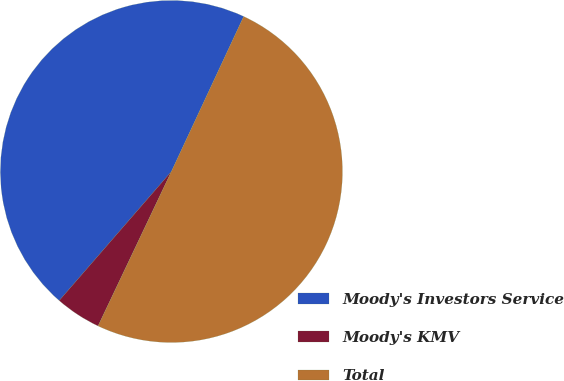<chart> <loc_0><loc_0><loc_500><loc_500><pie_chart><fcel>Moody's Investors Service<fcel>Moody's KMV<fcel>Total<nl><fcel>45.56%<fcel>4.33%<fcel>50.11%<nl></chart> 